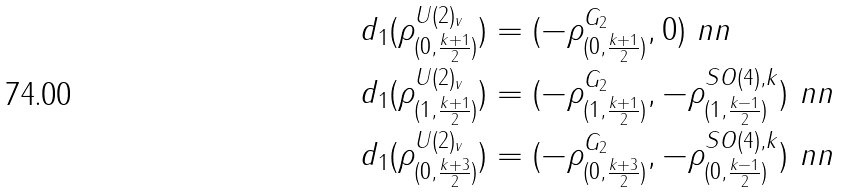<formula> <loc_0><loc_0><loc_500><loc_500>d _ { 1 } ( \rho ^ { U ( 2 ) _ { v } } _ { ( 0 , \frac { k + 1 } { 2 } ) } ) & = ( - \rho ^ { G _ { 2 } } _ { ( 0 , \frac { k + 1 } { 2 } ) } , 0 ) \ n n \\ d _ { 1 } ( \rho ^ { U ( 2 ) _ { v } } _ { ( 1 , \frac { k + 1 } { 2 } ) } ) & = ( - \rho ^ { G _ { 2 } } _ { ( 1 , \frac { k + 1 } { 2 } ) } , - \rho ^ { S O ( 4 ) , k } _ { ( 1 , \frac { k - 1 } { 2 } ) } ) \ n n \\ d _ { 1 } ( \rho ^ { U ( 2 ) _ { v } } _ { ( 0 , \frac { k + 3 } { 2 } ) } ) & = ( - \rho ^ { G _ { 2 } } _ { ( 0 , \frac { k + 3 } { 2 } ) } , - \rho ^ { S O ( 4 ) , k } _ { ( 0 , \frac { k - 1 } { 2 } ) } ) \ n n</formula> 